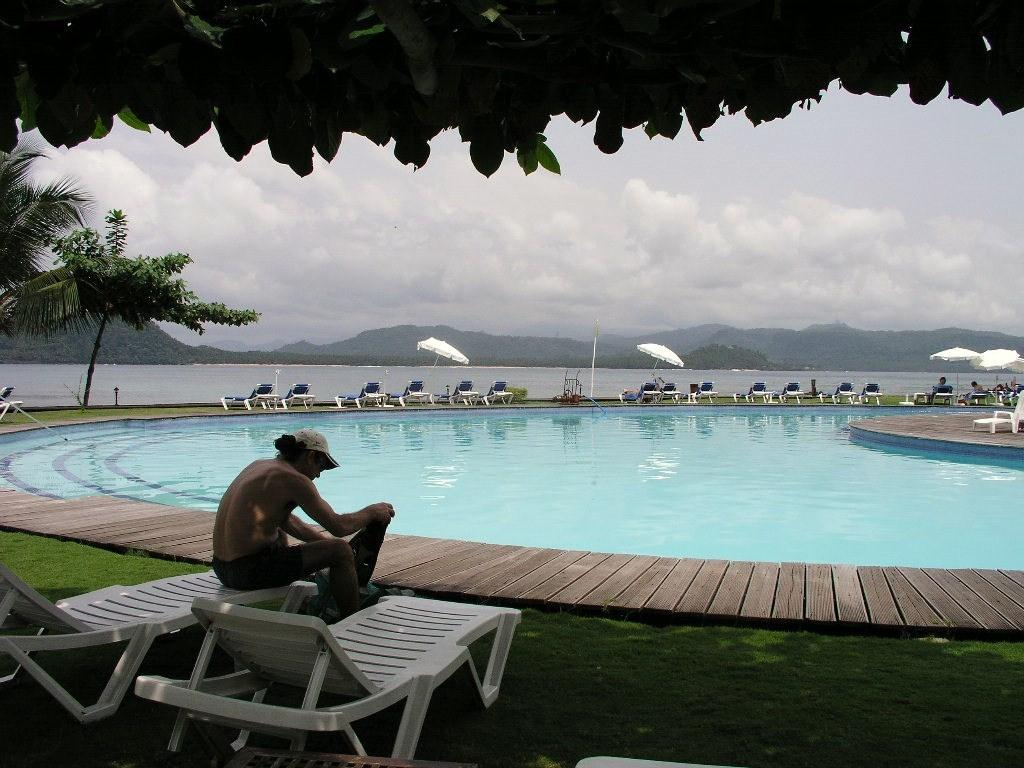What is the person in the image sitting on? The person is sitting on a pool bench in the image. What can be seen in front of the person? There is a big swimming pool in front of the person. How many pool benches are visible in the image? There are pool benches in the image. What provides shade in the image? There is an umbrella in the image. What is the condition of the water in the swimming pool? Water is visible in the swimming pool. What can be seen in the background of the image? There are mountains in the background of the image. What type of juice is being served under the tent in the image? There is no tent or juice present in the image. 